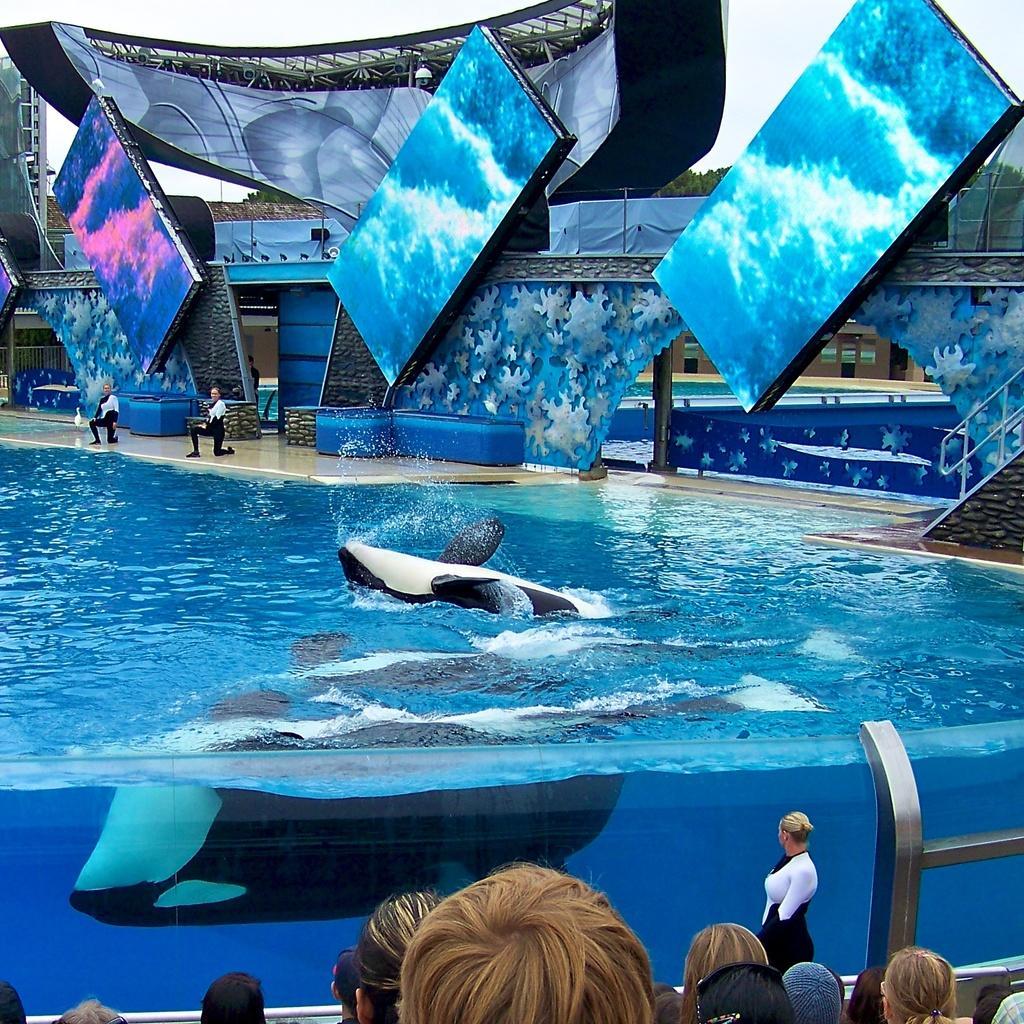Describe this image in one or two sentences. In this image, we can see some water. There are a few people. We can see some objects floating on the water. We can see the railing. We can see some hoardings. Among them, a few are digital hoardings. There are some trees. We can see the ground and the sky. We can also see a ladder. 